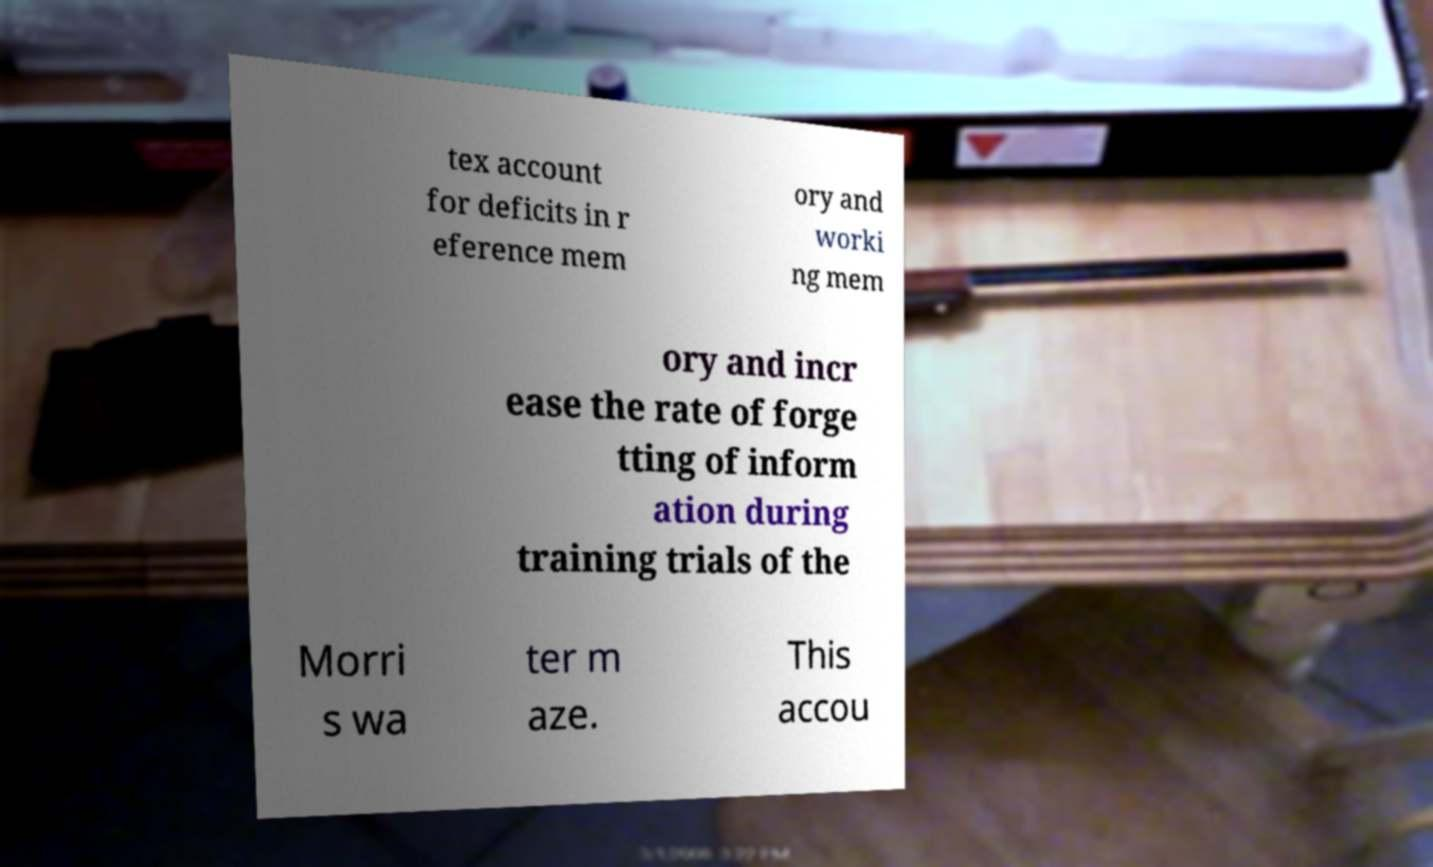Please read and relay the text visible in this image. What does it say? tex account for deficits in r eference mem ory and worki ng mem ory and incr ease the rate of forge tting of inform ation during training trials of the Morri s wa ter m aze. This accou 